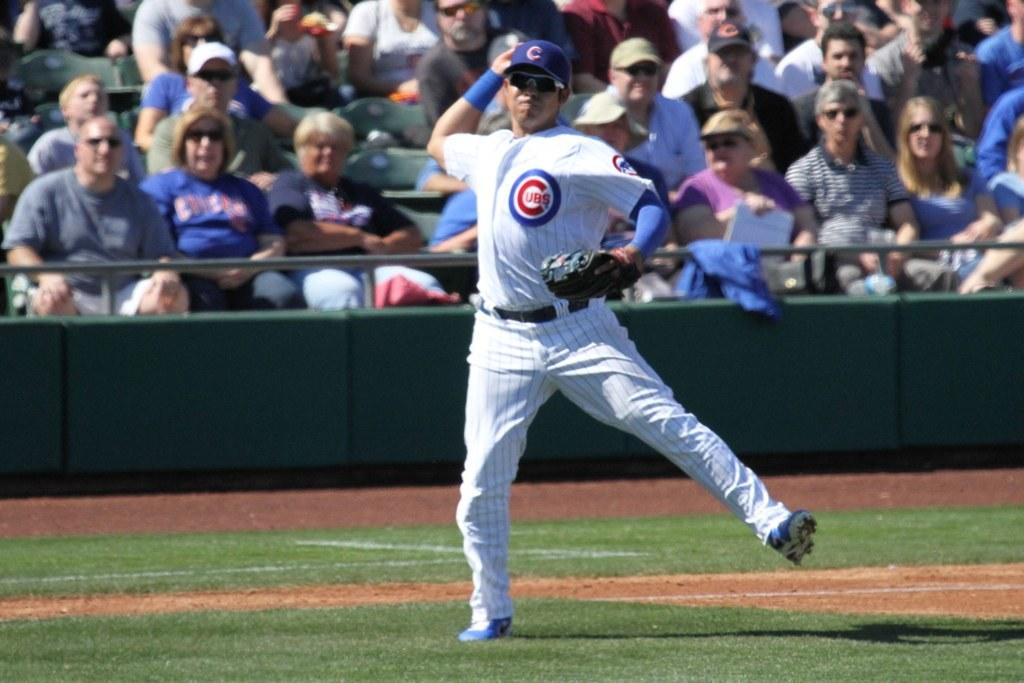What is the main subject of the image? There is a man in the image. What is the man doing in the image? The man is standing and throwing something. What is the man wearing on his left hand? The man is wearing a glove on his left hand. Are there any other people visible in the image? Yes, there are spectators behind the man. What type of crate is being used by the man in the image? There is no crate present in the image. What appliance is the man using to throw the object in the image? The man is not using an appliance to throw the object; he is using his hand. 